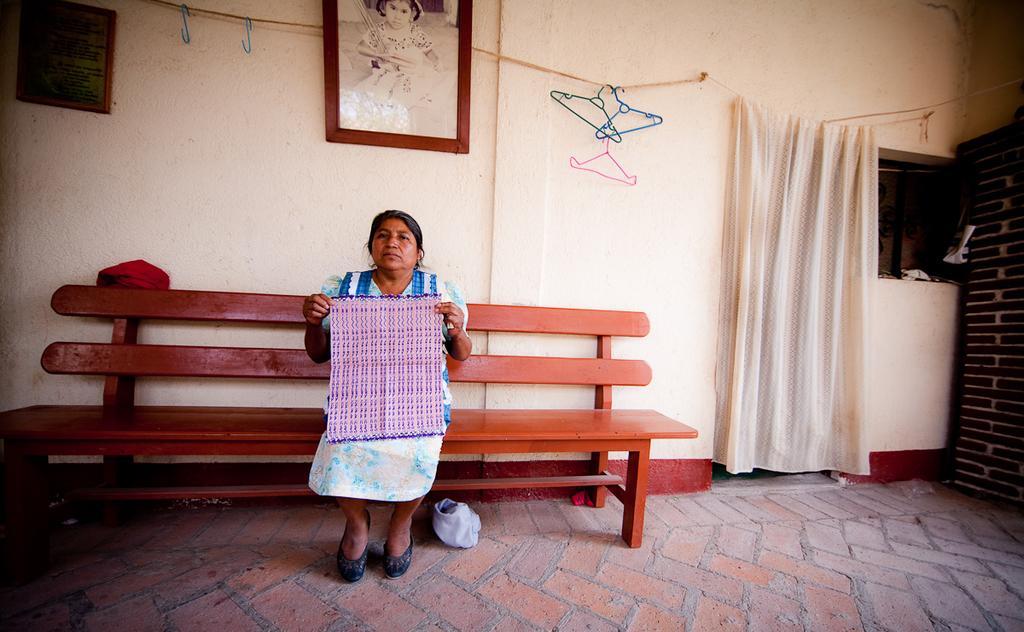Please provide a concise description of this image. In this image I see a woman holding a cloth and she is sitting on a bench. In the background I can see the wall and 2 photo frames on it and I can also see few hangers and the curtain. 